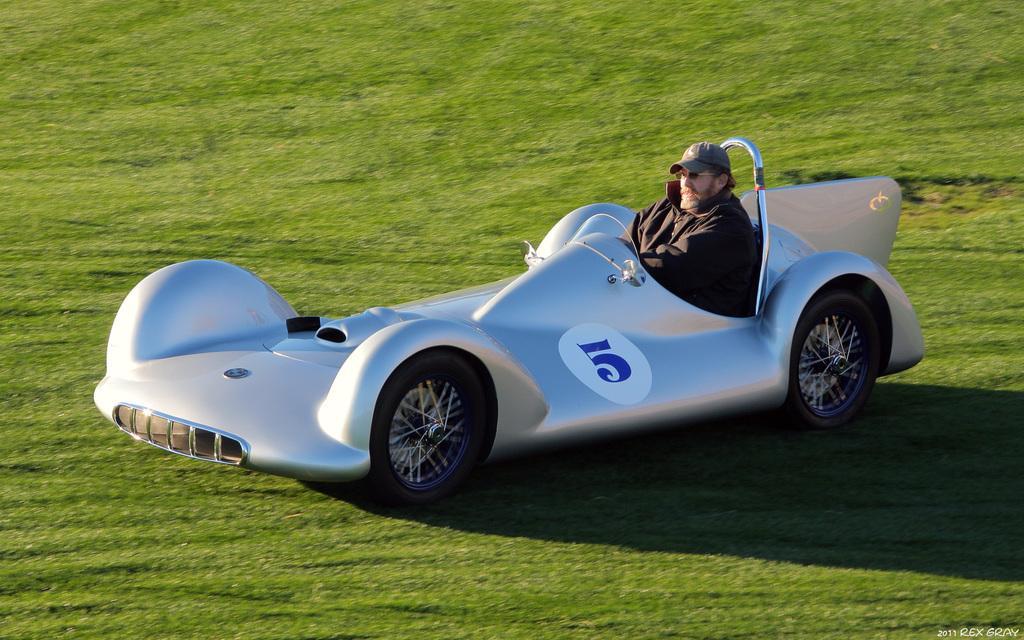What is the main subject of the image? The main subject of the image is a man. What is the man doing in the image? The man is riding a sports car. What is the man wearing in the image? The man is wearing a black jacket and a cap. What type of terrain can be seen in the image? There is grass visible in the image. How many geese are flying over the man in the image? There are no geese present in the image. What type of flowers can be seen in the background of the image? There are no flowers visible in the image. 